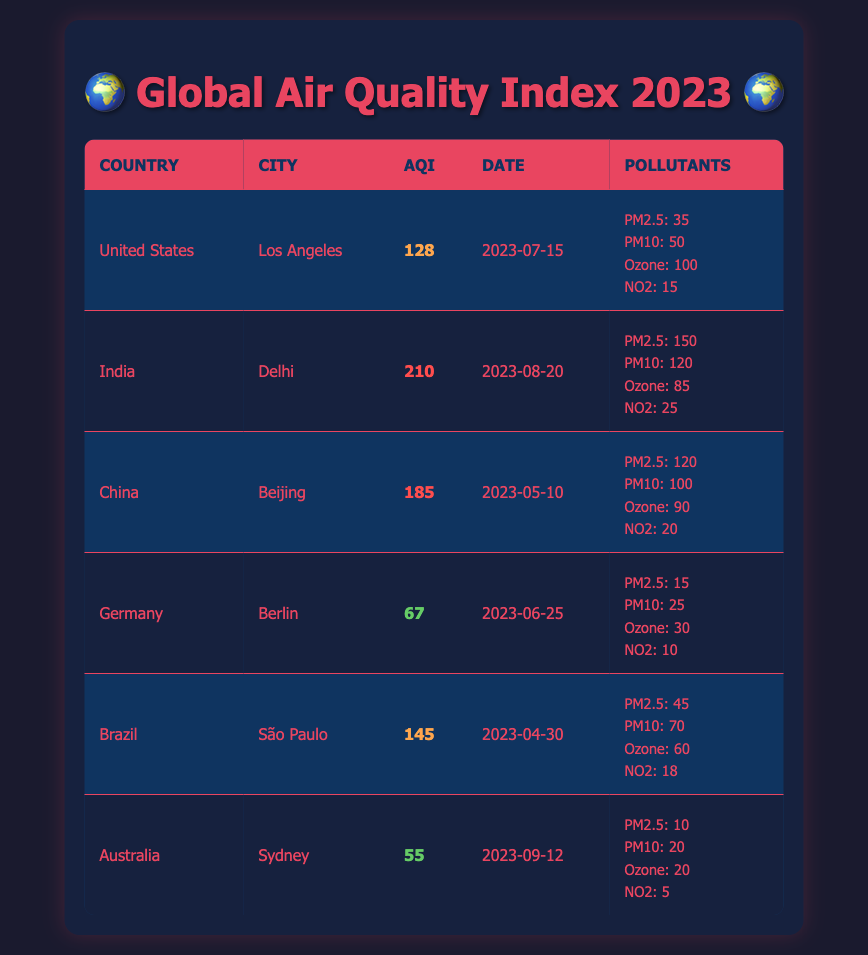What is the highest Air Quality Index (AQI) recorded in the table? The highest AQI can be found by comparing the AQI values in the table. Upon examining, the AQI for Delhi, India, is 210, which is the highest of all recorded values.
Answer: 210 Which city has the lowest Air Quality Index (AQI)? By looking through the AQI values, the lowest AQI is found in Sydney, Australia, with a value of 55.
Answer: 55 Are there any countries listed that have an AQI above 150? By reviewing the table, Delhi (India) has an AQI of 210 and Beijing (China) has an AQI of 185, both exceeding 150. Therefore, yes, there are countries listed with an AQI above 150.
Answer: Yes What is the average AQI of the cities listed in the table? To find the average AQI, add the AQI values (128 + 210 + 185 + 67 + 145 + 55) = 790. Then divide by the number of cities, which is 6. Hence, the average AQI is 790/6 = approximately 131.67.
Answer: Approximately 131.67 How many cities have an AQI classified as low (below 100)? The cities with AQI values classified as low are Berlin (Germany) with 67 and Sydney (Australia) with 55. So, there are 2 cities with an AQI below 100.
Answer: 2 What is the total amount of PM2.5 pollutants measured in the cities listed? The PM2.5 values are 35 (Los Angeles) + 150 (Delhi) + 120 (Beijing) + 15 (Berlin) + 45 (São Paulo) + 10 (Sydney) = 375. Therefore, the total amount of PM2.5 pollutants across all cities is 375.
Answer: 375 Is the city of São Paulo exceeding the Ozone level of 60? São Paulo reports an Ozone level of 60. Checking if it exceeds: 60 is not greater than 60. Thus, it does not exceed the value.
Answer: No Which country has the highest level of PM10, and what is the measurement? Upon evaluating the PM10 values, Delhi has the highest at 120. Thus, India has the highest PM10 level.
Answer: India, 120 